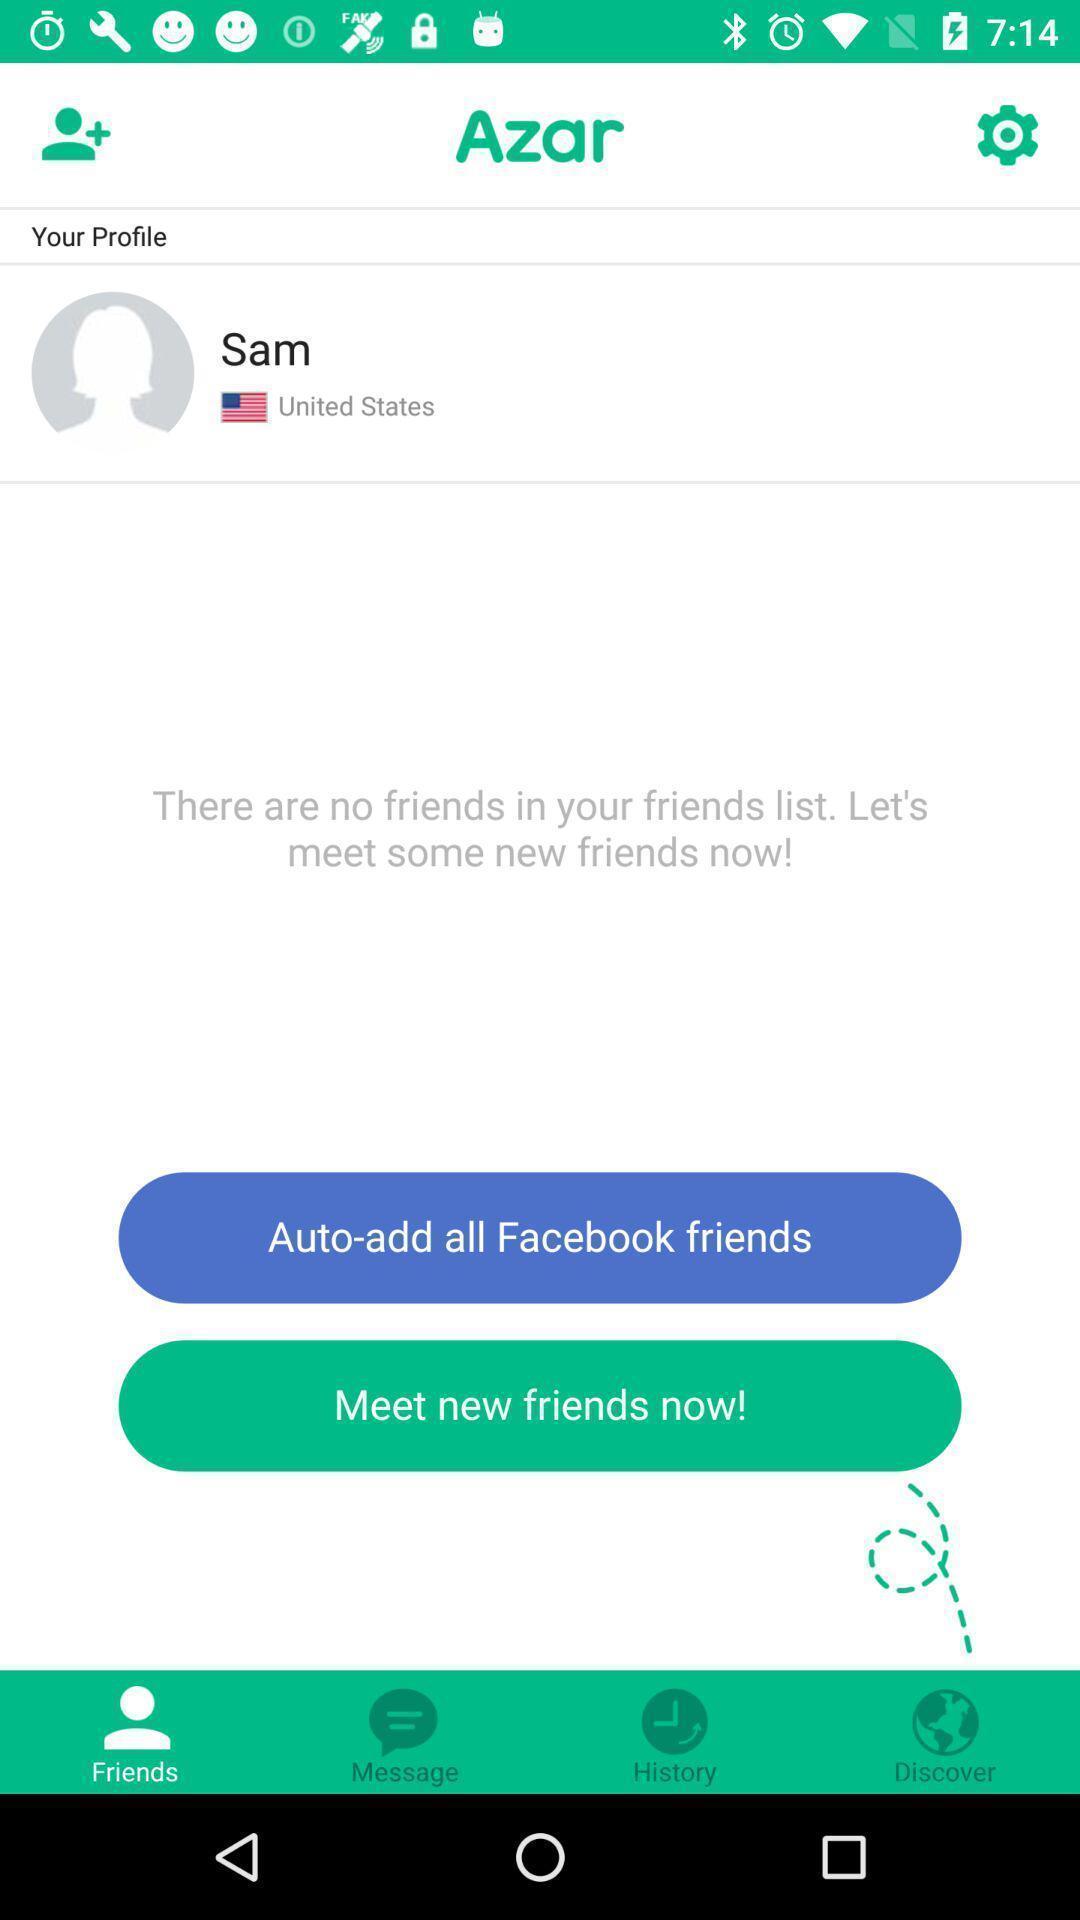Give me a summary of this screen capture. Screen displaying the friends page in a social app. 